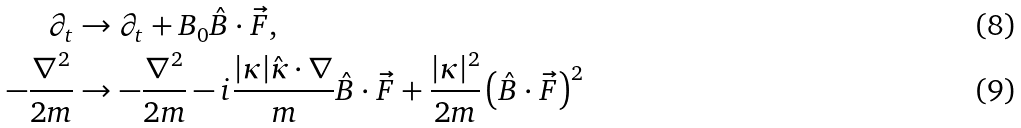<formula> <loc_0><loc_0><loc_500><loc_500>\partial _ { t } & \rightarrow \partial _ { t } + B _ { 0 } \hat { B } \cdot \vec { F } , & \\ - \frac { \nabla ^ { 2 } } { 2 m } & \rightarrow - \frac { \nabla ^ { 2 } } { 2 m } - i \frac { | \kappa | \hat { \kappa } \cdot \nabla } { m } \hat { B } \cdot \vec { F } + \frac { | \kappa | ^ { 2 } } { 2 m } \left ( \hat { B } \cdot \vec { F } \right ) ^ { 2 }</formula> 